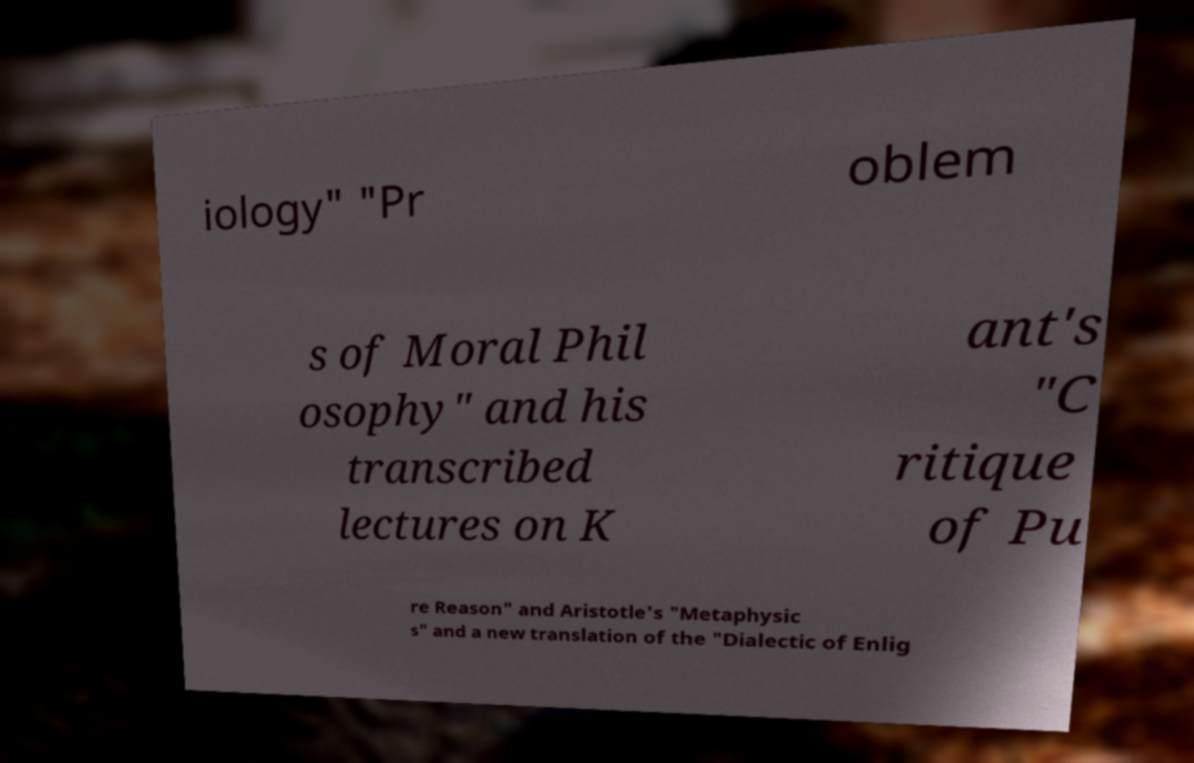For documentation purposes, I need the text within this image transcribed. Could you provide that? iology" "Pr oblem s of Moral Phil osophy" and his transcribed lectures on K ant's "C ritique of Pu re Reason" and Aristotle's "Metaphysic s" and a new translation of the "Dialectic of Enlig 